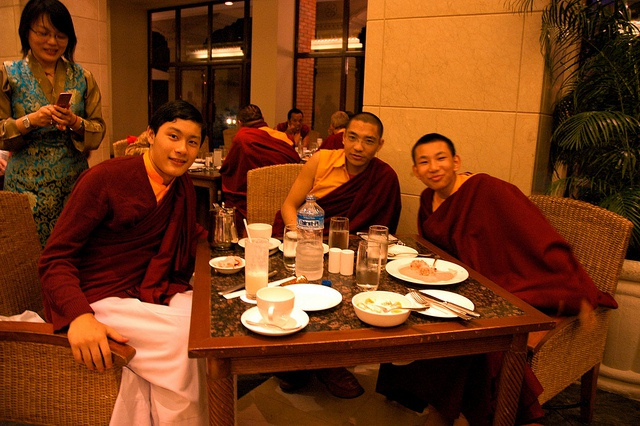Describe the objects in this image and their specific colors. I can see people in brown, black, maroon, salmon, and red tones, dining table in brown, maroon, and black tones, potted plant in brown, black, and maroon tones, people in brown, black, maroon, and olive tones, and people in brown, maroon, black, and red tones in this image. 